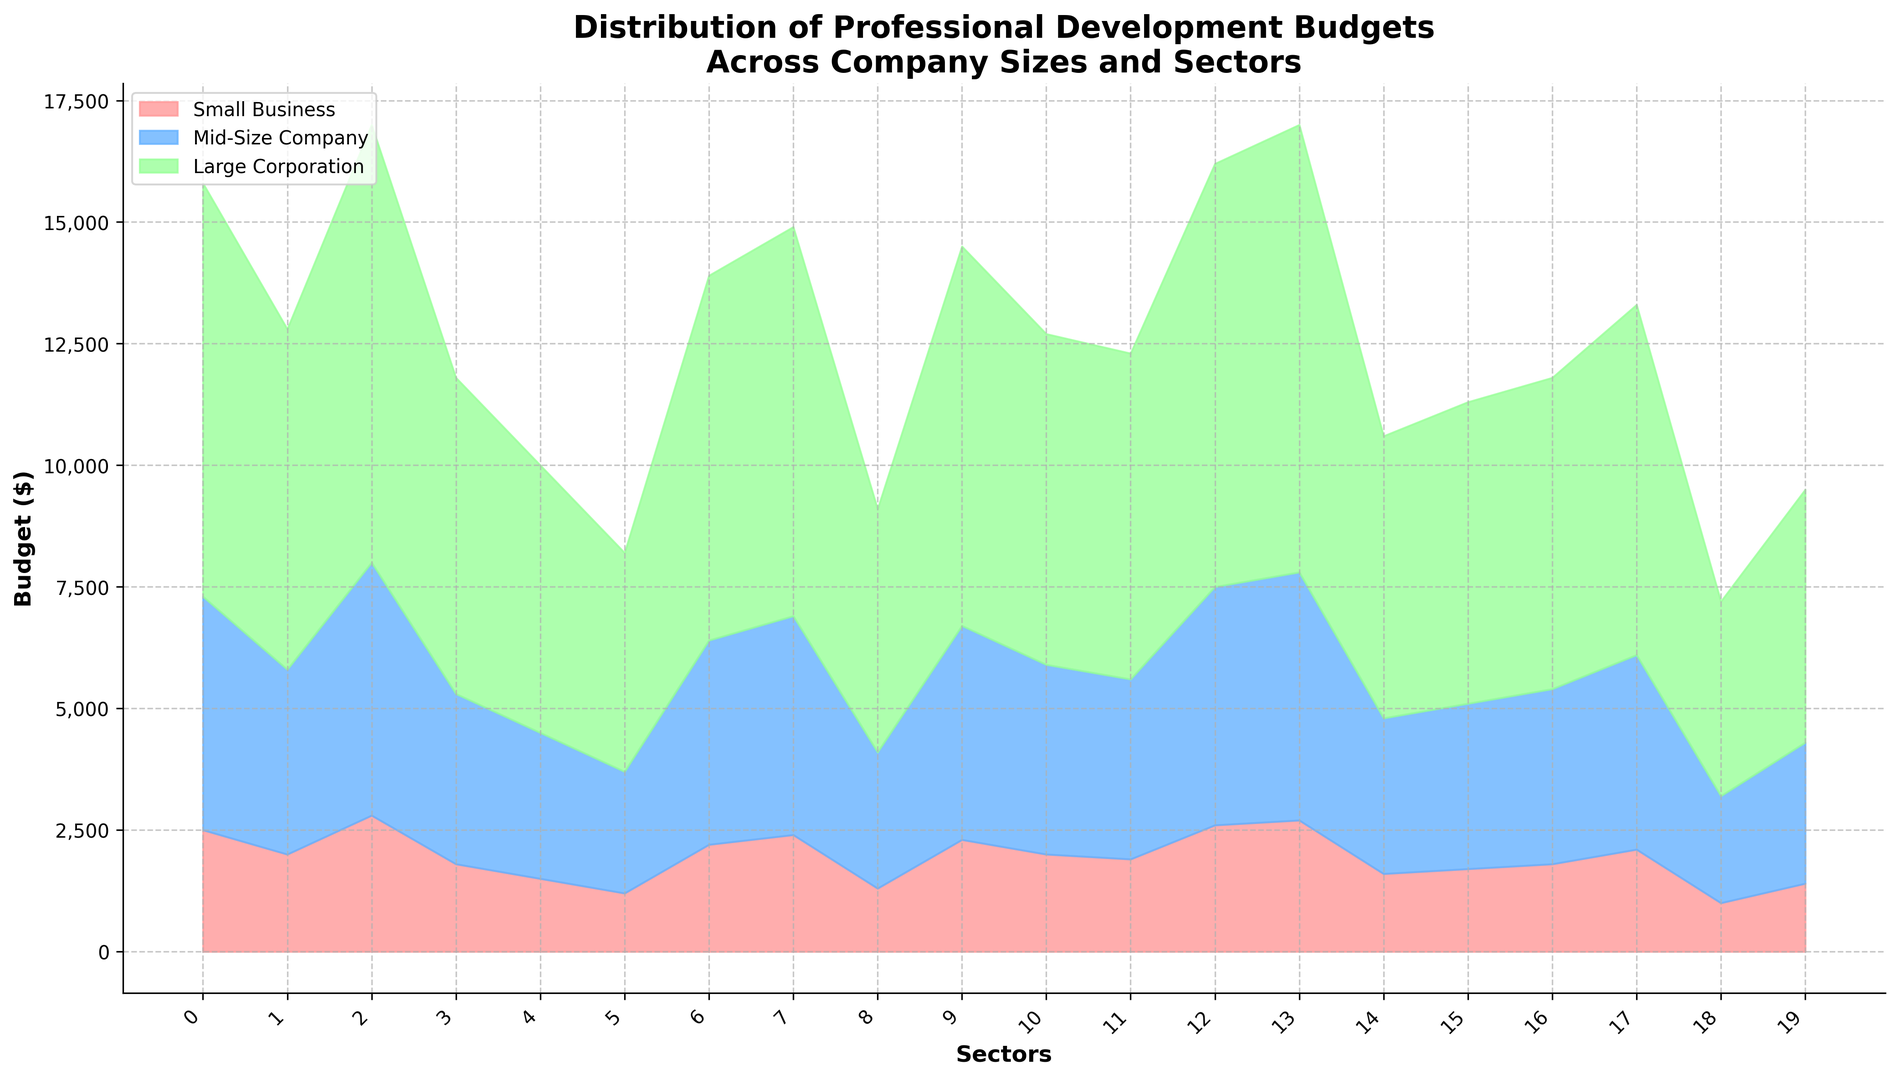What is the total budget for professional development in the Technology sector across all company sizes? First, identify the budget values for Small Business (2,500), Mid-Size Company (4,800), and Large Corporation (8,500) in the Technology sector from the chart. Add them together: 2,500 + 4,800 + 8,500 = 15,800.
Answer: 15,800 Which sector has the lowest professional development budget in Large Corporations, and how does it compare to the highest budget in Large Corporations? From the chart, identify the lowest budget for Large Corporations which is Non-Profit (4,000) and the highest budget is Pharmaceuticals (9,200). Compare the two: Pharmaceuticals (9,200) - Non-Profit (4,000) = 5,200.
Answer: Non-Profit, 5,200 Which sector allocates more budget to Small Businesses compared to Mid-Size Companies? Look at the chart for sectors where Small Business budget values are higher than Mid-Size Company budget values. Consulting (2,200 for Small Business vs. 4,200 for Mid-Size Company) is such a sector.
Answer: None What is the average budget for professional development across all sectors for Mid-Size Companies? Sum all the Mid-Size Company budget values from the chart and divide by the number of sectors (20). Total sum = 77,200. Average = 77,200 / 20 = 3,860.
Answer: 3,860 In the Finance sector, how much higher is the budget for Large Corporations compared to Small Businesses? Identify the budget values for Large Corporations (9,000) and Small Businesses (2,800) in the Finance sector. Subtract the Small Business budget from the Large Corporation budget: 9,000 - 2,800 = 6,200.
Answer: 6,200 Which sector has the most equal distribution of professional development budgets across all company sizes, and what does that distribution look like? Look for sectors where the bars for Small Business, Mid-Size Company, and Large Corporation are closest in height. Education has the closest distribution (1,200, 2,500, 4,500).
Answer: Education (1,200, 2,500, 4,500) How does the budget for Large Corporations in Healthcare compare to the budget for Small Businesses in Pharmaceuticals? From the chart, identify the budget for Large Corporations in Healthcare (7,000) and Small Businesses in Pharmaceuticals (2,700). Compare the two: 7,000 is greater than 2,700.
Answer: Healthcare is higher by 4,300 What is the difference in the professional development budgets for Large Corporations between the Technology and Automotive sectors? Identify the values for Large Corporations in Technology (8,500) and Automotive (6,700). Subtract Automotive budget from Technology budget: 8,500 - 6,700 = 1,800.
Answer: 1,800 Which company size has the highest budget in the Government sector, and what is that value? Identify the highest budget for the Government sector from the chart. The highest budget in Government is for Large Corporations (5,200).
Answer: Large Corporations, 5,200 